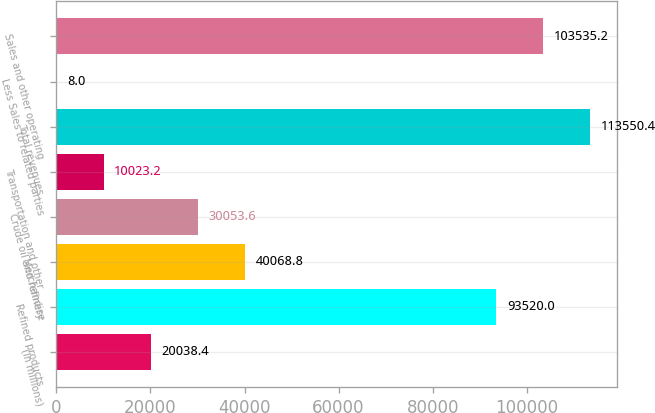Convert chart to OTSL. <chart><loc_0><loc_0><loc_500><loc_500><bar_chart><fcel>(In millions)<fcel>Refined products<fcel>Merchandise<fcel>Crude oil and refinery<fcel>Transportation and other<fcel>Total revenues<fcel>Less Sales to related parties<fcel>Sales and other operating<nl><fcel>20038.4<fcel>93520<fcel>40068.8<fcel>30053.6<fcel>10023.2<fcel>113550<fcel>8<fcel>103535<nl></chart> 